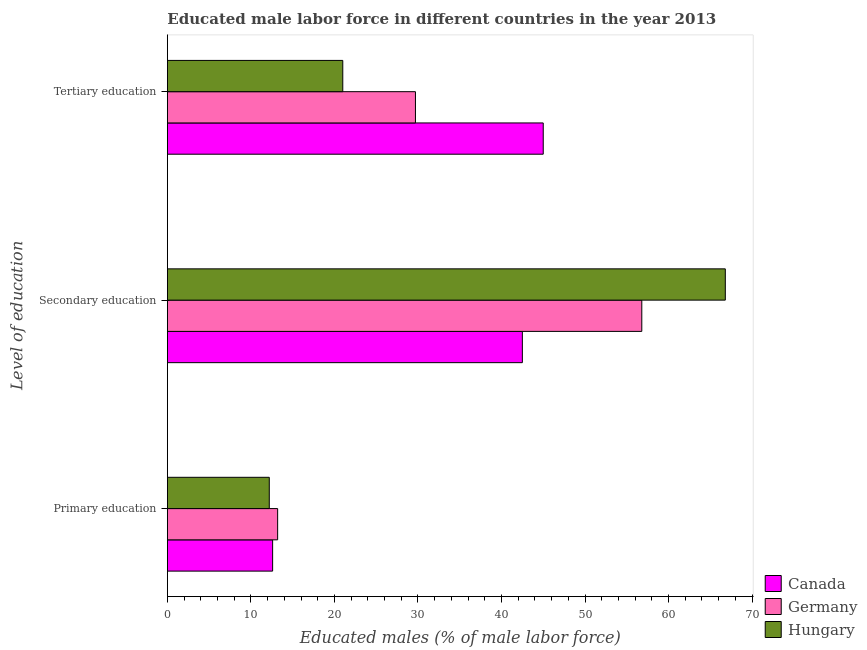Are the number of bars per tick equal to the number of legend labels?
Your response must be concise. Yes. Are the number of bars on each tick of the Y-axis equal?
Offer a terse response. Yes. How many bars are there on the 1st tick from the top?
Your answer should be compact. 3. What is the label of the 2nd group of bars from the top?
Your answer should be compact. Secondary education. What is the percentage of male labor force who received primary education in Germany?
Offer a terse response. 13.2. Across all countries, what is the maximum percentage of male labor force who received primary education?
Provide a succinct answer. 13.2. In which country was the percentage of male labor force who received secondary education minimum?
Your answer should be very brief. Canada. What is the total percentage of male labor force who received primary education in the graph?
Your answer should be compact. 38. What is the difference between the percentage of male labor force who received primary education in Hungary and that in Germany?
Give a very brief answer. -1. What is the difference between the percentage of male labor force who received primary education in Canada and the percentage of male labor force who received tertiary education in Hungary?
Ensure brevity in your answer.  -8.4. What is the average percentage of male labor force who received tertiary education per country?
Offer a very short reply. 31.9. What is the difference between the percentage of male labor force who received tertiary education and percentage of male labor force who received primary education in Germany?
Your answer should be very brief. 16.5. What is the ratio of the percentage of male labor force who received primary education in Germany to that in Hungary?
Offer a very short reply. 1.08. What is the difference between the highest and the second highest percentage of male labor force who received tertiary education?
Offer a terse response. 15.3. What is the difference between the highest and the lowest percentage of male labor force who received secondary education?
Make the answer very short. 24.3. Is the sum of the percentage of male labor force who received primary education in Hungary and Germany greater than the maximum percentage of male labor force who received tertiary education across all countries?
Offer a terse response. No. What does the 1st bar from the top in Secondary education represents?
Offer a terse response. Hungary. What does the 3rd bar from the bottom in Tertiary education represents?
Offer a very short reply. Hungary. What is the difference between two consecutive major ticks on the X-axis?
Provide a short and direct response. 10. Are the values on the major ticks of X-axis written in scientific E-notation?
Give a very brief answer. No. Where does the legend appear in the graph?
Give a very brief answer. Bottom right. What is the title of the graph?
Give a very brief answer. Educated male labor force in different countries in the year 2013. What is the label or title of the X-axis?
Offer a terse response. Educated males (% of male labor force). What is the label or title of the Y-axis?
Your answer should be very brief. Level of education. What is the Educated males (% of male labor force) of Canada in Primary education?
Keep it short and to the point. 12.6. What is the Educated males (% of male labor force) in Germany in Primary education?
Your response must be concise. 13.2. What is the Educated males (% of male labor force) in Hungary in Primary education?
Offer a terse response. 12.2. What is the Educated males (% of male labor force) in Canada in Secondary education?
Offer a terse response. 42.5. What is the Educated males (% of male labor force) in Germany in Secondary education?
Offer a terse response. 56.8. What is the Educated males (% of male labor force) in Hungary in Secondary education?
Keep it short and to the point. 66.8. What is the Educated males (% of male labor force) of Germany in Tertiary education?
Provide a short and direct response. 29.7. What is the Educated males (% of male labor force) in Hungary in Tertiary education?
Ensure brevity in your answer.  21. Across all Level of education, what is the maximum Educated males (% of male labor force) of Canada?
Make the answer very short. 45. Across all Level of education, what is the maximum Educated males (% of male labor force) of Germany?
Provide a succinct answer. 56.8. Across all Level of education, what is the maximum Educated males (% of male labor force) in Hungary?
Ensure brevity in your answer.  66.8. Across all Level of education, what is the minimum Educated males (% of male labor force) in Canada?
Keep it short and to the point. 12.6. Across all Level of education, what is the minimum Educated males (% of male labor force) of Germany?
Ensure brevity in your answer.  13.2. Across all Level of education, what is the minimum Educated males (% of male labor force) in Hungary?
Offer a terse response. 12.2. What is the total Educated males (% of male labor force) of Canada in the graph?
Offer a terse response. 100.1. What is the total Educated males (% of male labor force) in Germany in the graph?
Keep it short and to the point. 99.7. What is the difference between the Educated males (% of male labor force) of Canada in Primary education and that in Secondary education?
Your answer should be compact. -29.9. What is the difference between the Educated males (% of male labor force) in Germany in Primary education and that in Secondary education?
Offer a very short reply. -43.6. What is the difference between the Educated males (% of male labor force) of Hungary in Primary education and that in Secondary education?
Offer a very short reply. -54.6. What is the difference between the Educated males (% of male labor force) of Canada in Primary education and that in Tertiary education?
Ensure brevity in your answer.  -32.4. What is the difference between the Educated males (% of male labor force) in Germany in Primary education and that in Tertiary education?
Keep it short and to the point. -16.5. What is the difference between the Educated males (% of male labor force) of Hungary in Primary education and that in Tertiary education?
Ensure brevity in your answer.  -8.8. What is the difference between the Educated males (% of male labor force) in Canada in Secondary education and that in Tertiary education?
Offer a very short reply. -2.5. What is the difference between the Educated males (% of male labor force) in Germany in Secondary education and that in Tertiary education?
Your answer should be very brief. 27.1. What is the difference between the Educated males (% of male labor force) in Hungary in Secondary education and that in Tertiary education?
Your answer should be very brief. 45.8. What is the difference between the Educated males (% of male labor force) of Canada in Primary education and the Educated males (% of male labor force) of Germany in Secondary education?
Offer a very short reply. -44.2. What is the difference between the Educated males (% of male labor force) in Canada in Primary education and the Educated males (% of male labor force) in Hungary in Secondary education?
Your response must be concise. -54.2. What is the difference between the Educated males (% of male labor force) in Germany in Primary education and the Educated males (% of male labor force) in Hungary in Secondary education?
Provide a succinct answer. -53.6. What is the difference between the Educated males (% of male labor force) in Canada in Primary education and the Educated males (% of male labor force) in Germany in Tertiary education?
Your response must be concise. -17.1. What is the difference between the Educated males (% of male labor force) in Germany in Primary education and the Educated males (% of male labor force) in Hungary in Tertiary education?
Your response must be concise. -7.8. What is the difference between the Educated males (% of male labor force) of Germany in Secondary education and the Educated males (% of male labor force) of Hungary in Tertiary education?
Provide a short and direct response. 35.8. What is the average Educated males (% of male labor force) in Canada per Level of education?
Ensure brevity in your answer.  33.37. What is the average Educated males (% of male labor force) in Germany per Level of education?
Give a very brief answer. 33.23. What is the average Educated males (% of male labor force) in Hungary per Level of education?
Keep it short and to the point. 33.33. What is the difference between the Educated males (% of male labor force) of Canada and Educated males (% of male labor force) of Hungary in Primary education?
Your answer should be very brief. 0.4. What is the difference between the Educated males (% of male labor force) of Canada and Educated males (% of male labor force) of Germany in Secondary education?
Your response must be concise. -14.3. What is the difference between the Educated males (% of male labor force) in Canada and Educated males (% of male labor force) in Hungary in Secondary education?
Ensure brevity in your answer.  -24.3. What is the difference between the Educated males (% of male labor force) in Canada and Educated males (% of male labor force) in Germany in Tertiary education?
Offer a very short reply. 15.3. What is the ratio of the Educated males (% of male labor force) in Canada in Primary education to that in Secondary education?
Provide a succinct answer. 0.3. What is the ratio of the Educated males (% of male labor force) of Germany in Primary education to that in Secondary education?
Make the answer very short. 0.23. What is the ratio of the Educated males (% of male labor force) in Hungary in Primary education to that in Secondary education?
Your answer should be very brief. 0.18. What is the ratio of the Educated males (% of male labor force) in Canada in Primary education to that in Tertiary education?
Your response must be concise. 0.28. What is the ratio of the Educated males (% of male labor force) of Germany in Primary education to that in Tertiary education?
Offer a terse response. 0.44. What is the ratio of the Educated males (% of male labor force) of Hungary in Primary education to that in Tertiary education?
Offer a very short reply. 0.58. What is the ratio of the Educated males (% of male labor force) of Canada in Secondary education to that in Tertiary education?
Your answer should be compact. 0.94. What is the ratio of the Educated males (% of male labor force) in Germany in Secondary education to that in Tertiary education?
Your answer should be very brief. 1.91. What is the ratio of the Educated males (% of male labor force) of Hungary in Secondary education to that in Tertiary education?
Your answer should be very brief. 3.18. What is the difference between the highest and the second highest Educated males (% of male labor force) in Germany?
Ensure brevity in your answer.  27.1. What is the difference between the highest and the second highest Educated males (% of male labor force) in Hungary?
Offer a very short reply. 45.8. What is the difference between the highest and the lowest Educated males (% of male labor force) in Canada?
Offer a very short reply. 32.4. What is the difference between the highest and the lowest Educated males (% of male labor force) in Germany?
Keep it short and to the point. 43.6. What is the difference between the highest and the lowest Educated males (% of male labor force) of Hungary?
Offer a terse response. 54.6. 